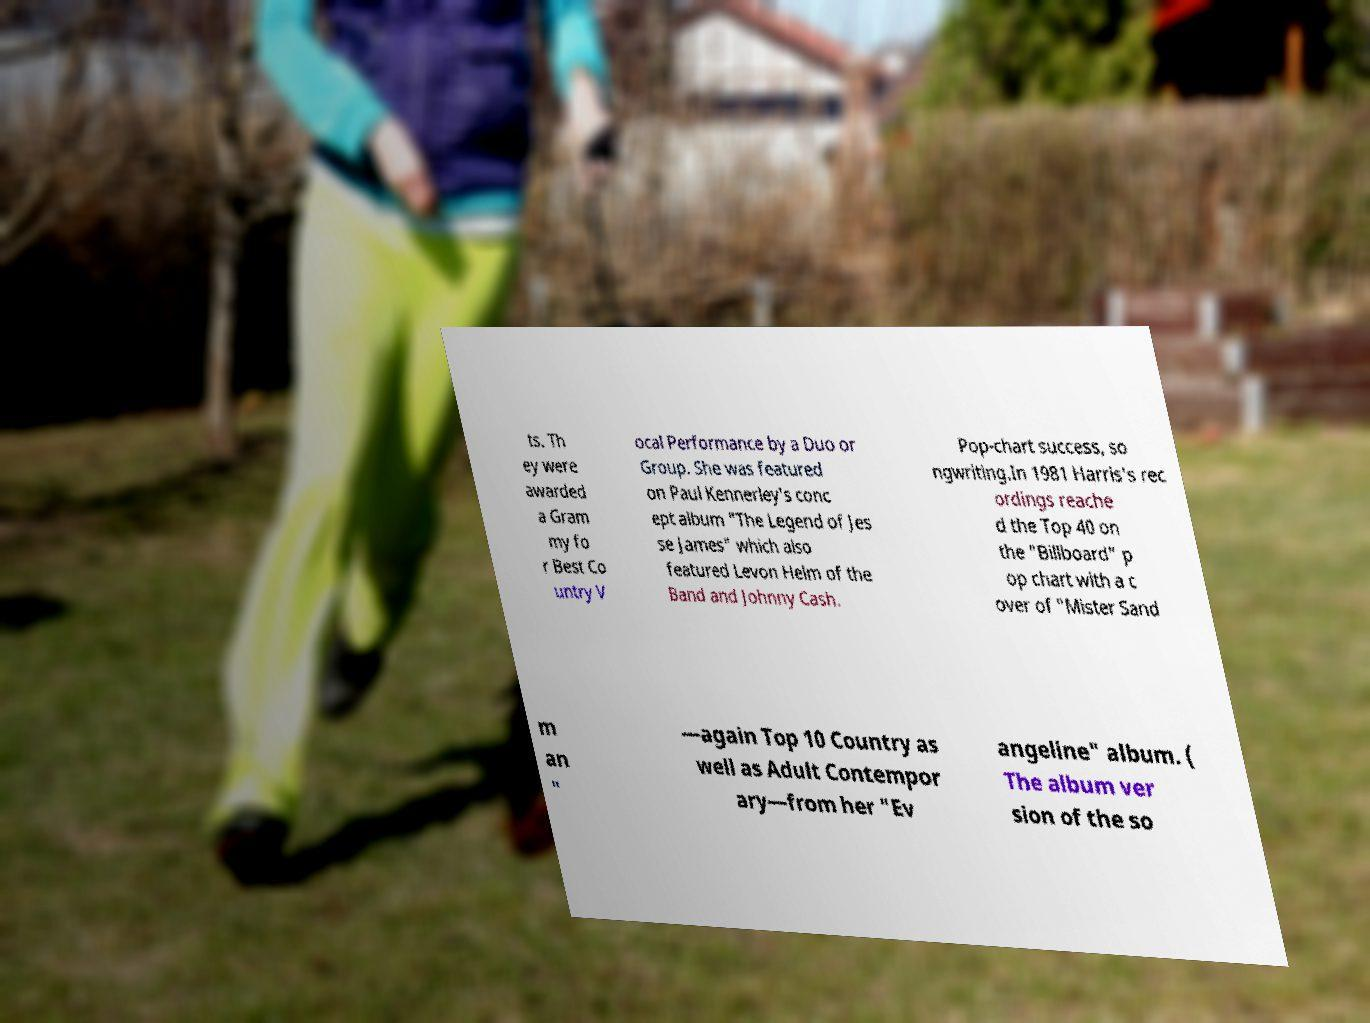What messages or text are displayed in this image? I need them in a readable, typed format. ts. Th ey were awarded a Gram my fo r Best Co untry V ocal Performance by a Duo or Group. She was featured on Paul Kennerley's conc ept album "The Legend of Jes se James" which also featured Levon Helm of the Band and Johnny Cash. Pop-chart success, so ngwriting.In 1981 Harris's rec ordings reache d the Top 40 on the "Billboard" p op chart with a c over of "Mister Sand m an " —again Top 10 Country as well as Adult Contempor ary—from her "Ev angeline" album. ( The album ver sion of the so 